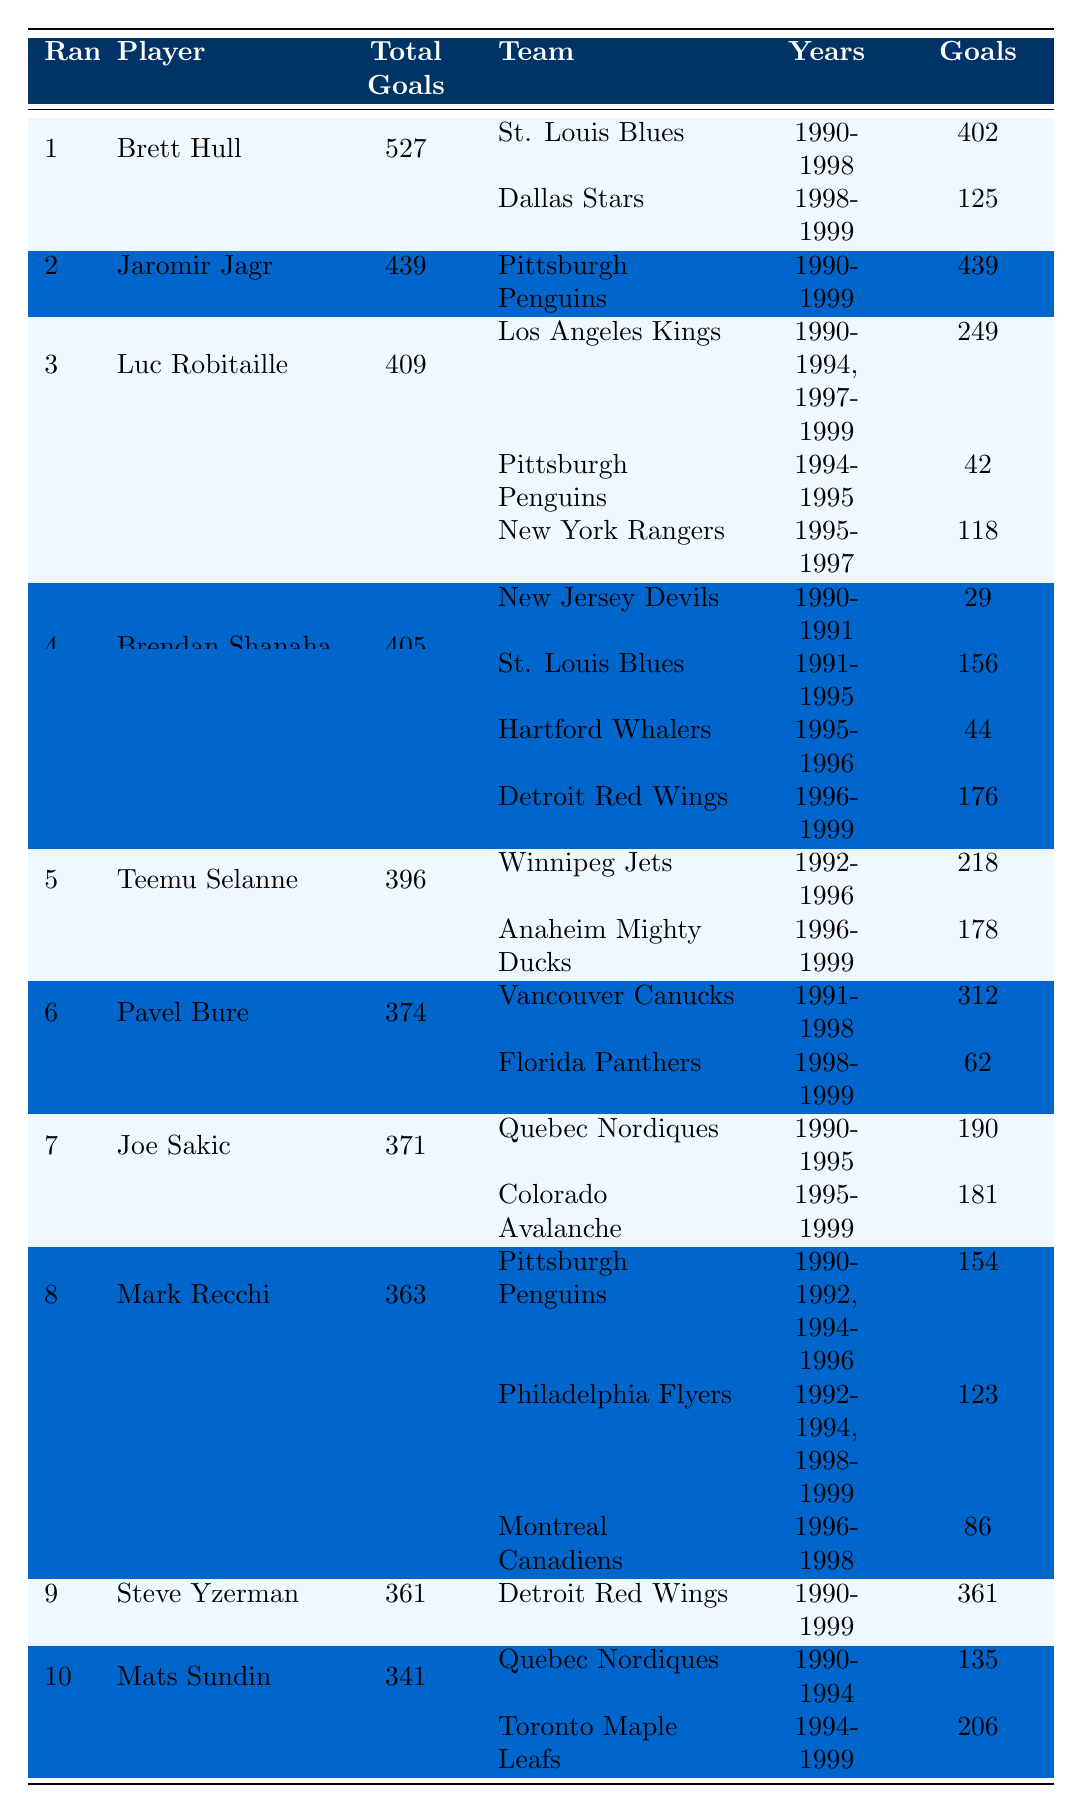What is the total number of goals scored by Brett Hull? Brett Hull scored a total of 527 goals, as indicated in the "Total Goals" column next to his name in the table.
Answer: 527 Which player scored the most goals while playing for the same team for the entire decade? Jaromir Jagr scored all of his 439 goals with the Pittsburgh Penguins, as shown in the table where his team affiliations list only one team from 1990 to 1999.
Answer: Yes How many goals did Luc Robitaille score with the Los Angeles Kings? Luc Robitaille scored 249 goals with the Los Angeles Kings as stated in the breakdown of his goals across different teams in the "Team Affiliations" section.
Answer: 249 Which player had the highest total goals but played for the most teams? Brett Hull had the highest total goals (527) and played for two different teams during the 1990s, as evidenced by the "Team Affiliations" listed.
Answer: Brett Hull What is the average number of goals scored by the top 3 goal scorers? The top 3 goal scorers are Brett Hull (527), Jaromir Jagr (439), and Luc Robitaille (409). Adding these gives 527 + 439 + 409 = 1375. Dividing by 3 gives an average of 1375 / 3 = 458.33.
Answer: 458.33 How many goals did Brendan Shanahan score while he was with the Detroit Red Wings? Brendan Shanahan scored 176 goals while playing for the Detroit Red Wings, as shown in the "Team Affiliations" list.
Answer: 176 Who scored the least number of goals in the top 10 list? Mats Sundin scored a total of 341 goals, which is the lowest among the top 10 scorers listed in the table.
Answer: 341 Across the players listed, how many total goals did all players score while with the Pittsburgh Penguins? The goals scored by players with the Pittsburgh Penguins are: Jaromir Jagr (439), Luc Robitaille (42), and Mark Recchi (154), which totals to 439 + 42 + 154 = 635 goals.
Answer: 635 Did any player score more goals after changing teams? Yes, Brett Hull scored more goals after joining the Dallas Stars (125) compared to his goals with the St. Louis Blues (402) but since this is within his total, it does not increase his overall number of goals.
Answer: Yes What percentage of his total goals did Teemu Selanne score while playing for the Winnipeg Jets? Teemu Selanne scored 218 goals with the Winnipeg Jets out of a total of 396 goals. To find the percentage, (218/396) * 100 = 55.03%.
Answer: 55.03% 